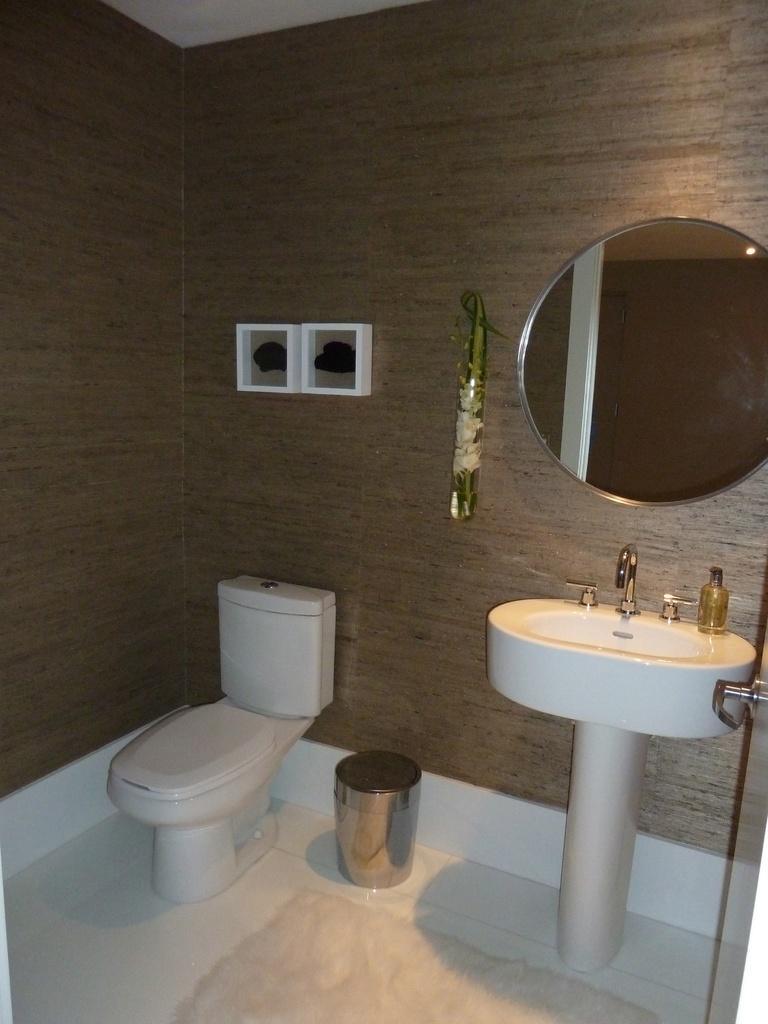Could you give a brief overview of what you see in this image? In this image, we can see commode, dustbin, sink with taps, bottle and handle. At the bottom of the image, we can see the floor and floor mat. In the background, there are showpieces and mirror on the wall. On this mirror, we can see reflections. 